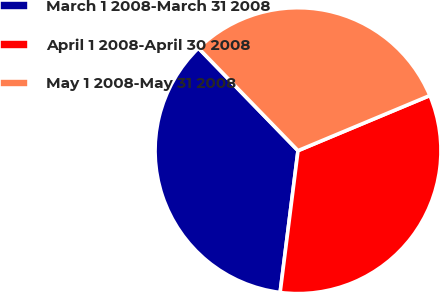Convert chart. <chart><loc_0><loc_0><loc_500><loc_500><pie_chart><fcel>March 1 2008-March 31 2008<fcel>April 1 2008-April 30 2008<fcel>May 1 2008-May 31 2008<nl><fcel>35.74%<fcel>33.3%<fcel>30.96%<nl></chart> 